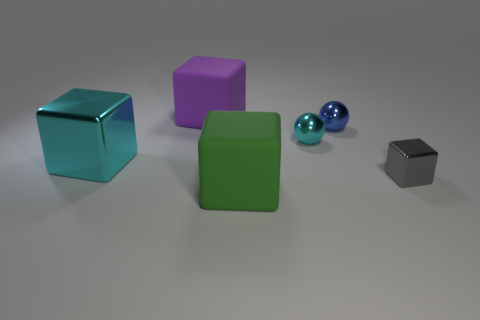Subtract all big purple blocks. How many blocks are left? 3 Subtract all blocks. How many objects are left? 2 Subtract all blue balls. How many balls are left? 1 Add 1 large cyan metallic cubes. How many objects exist? 7 Subtract all green spheres. How many cyan cubes are left? 1 Subtract all brown blocks. Subtract all cyan metallic blocks. How many objects are left? 5 Add 1 large objects. How many large objects are left? 4 Add 4 brown objects. How many brown objects exist? 4 Subtract 0 yellow cubes. How many objects are left? 6 Subtract all purple blocks. Subtract all green balls. How many blocks are left? 3 